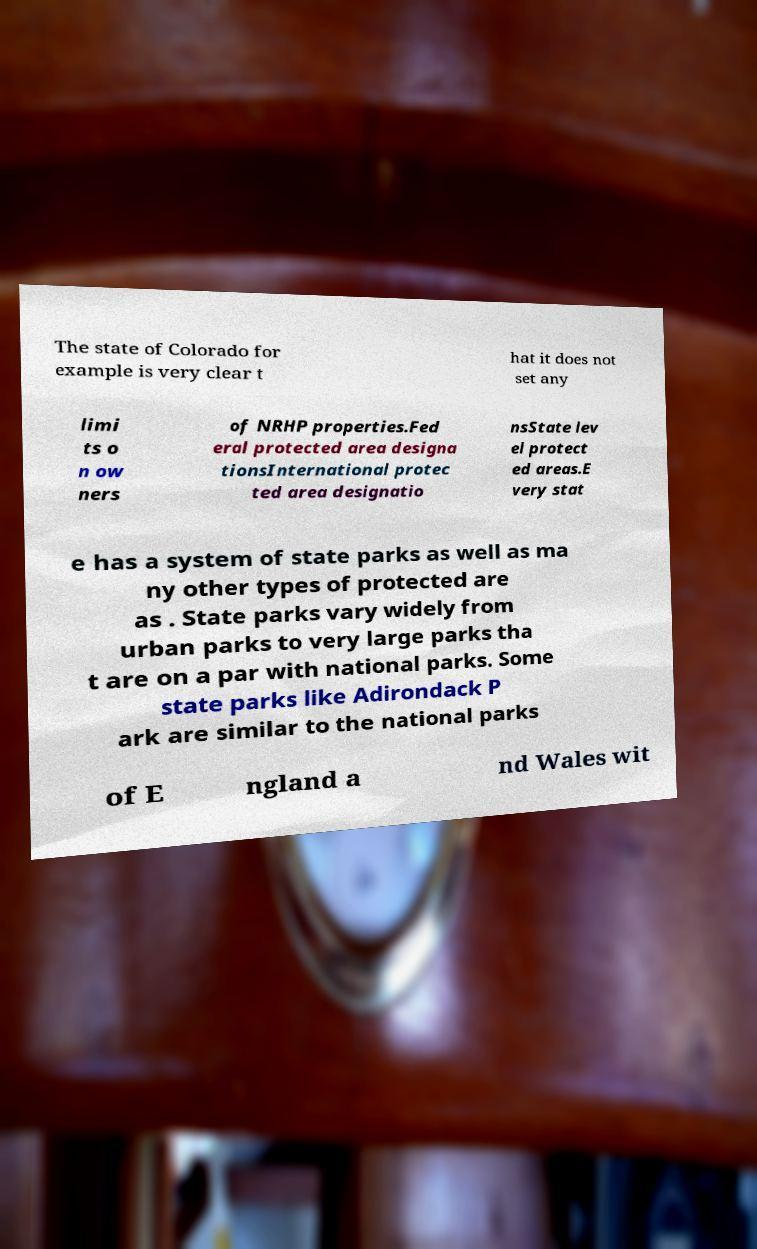Can you read and provide the text displayed in the image?This photo seems to have some interesting text. Can you extract and type it out for me? The state of Colorado for example is very clear t hat it does not set any limi ts o n ow ners of NRHP properties.Fed eral protected area designa tionsInternational protec ted area designatio nsState lev el protect ed areas.E very stat e has a system of state parks as well as ma ny other types of protected are as . State parks vary widely from urban parks to very large parks tha t are on a par with national parks. Some state parks like Adirondack P ark are similar to the national parks of E ngland a nd Wales wit 